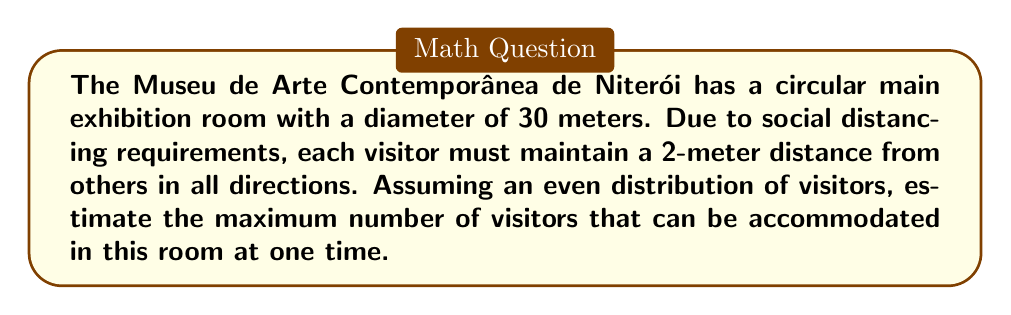Teach me how to tackle this problem. Let's approach this step-by-step:

1) First, we need to calculate the area of the circular room:
   Area = $\pi r^2$, where $r$ is the radius
   Radius = diameter / 2 = 30 / 2 = 15 meters
   Area = $\pi (15)^2 = 225\pi \approx 706.86$ square meters

2) Now, we need to determine the area each visitor occupies due to social distancing:
   Each visitor needs a 2-meter radius around them
   Area per visitor = $\pi r^2 = \pi (2)^2 = 4\pi \approx 12.57$ square meters

3) To estimate the number of visitors, we divide the total area by the area per visitor:
   Number of visitors = Total area / Area per visitor
   $$ \text{Number of visitors} = \frac{225\pi}{4\pi} = \frac{225}{4} = 56.25 $$

4) Since we can't have a fraction of a person, we round down to the nearest whole number:
   Maximum number of visitors = 56

Note: This is an estimate assuming perfect distribution. In reality, the number might be slightly lower due to practical space constraints and movement considerations.
Answer: 56 visitors 